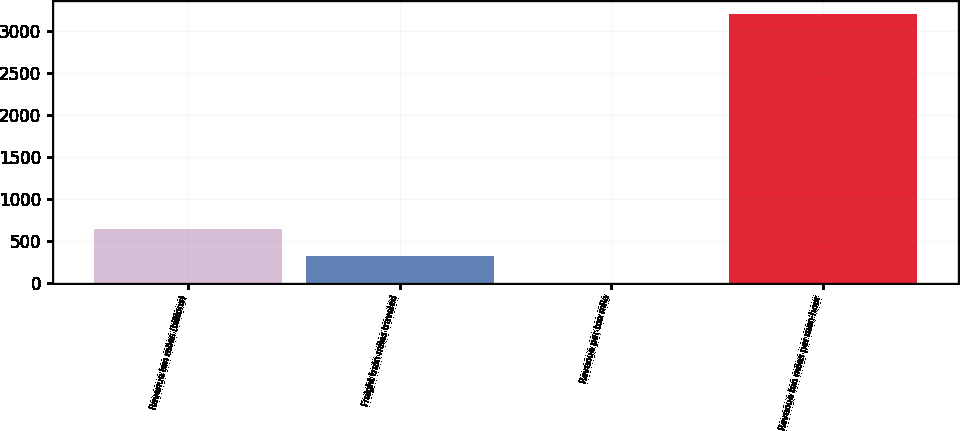Convert chart. <chart><loc_0><loc_0><loc_500><loc_500><bar_chart><fcel>Revenue ton miles (billions)<fcel>Freight train miles traveled<fcel>Revenue per ton mile<fcel>Revenue ton miles per man-hour<nl><fcel>639.25<fcel>319.65<fcel>0.05<fcel>3196<nl></chart> 